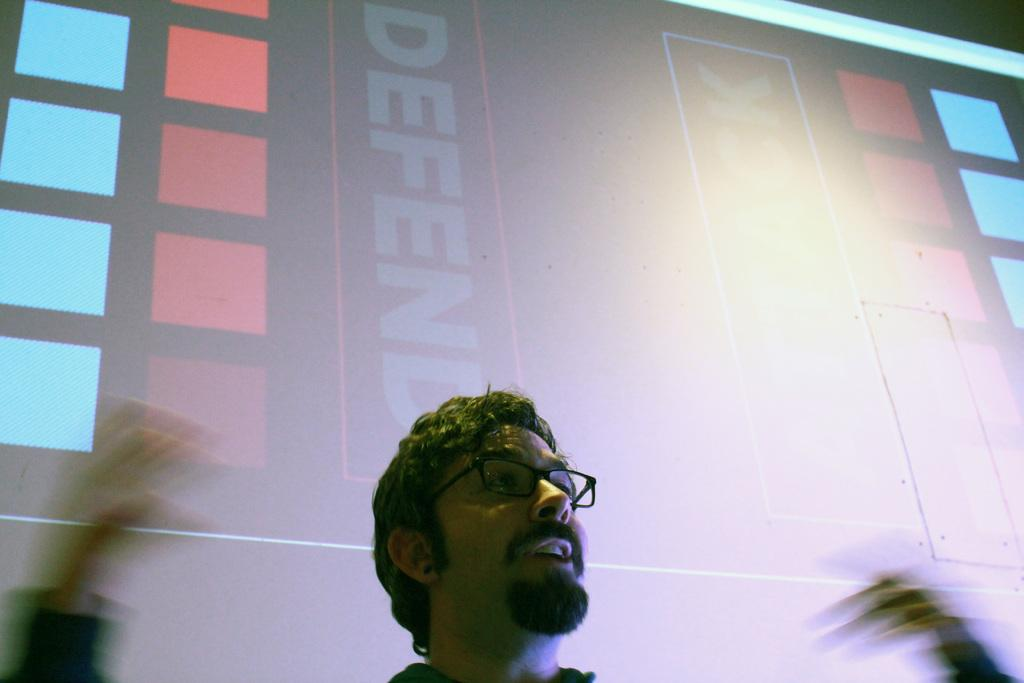Who is present in the image? There is a person in the image. What can be observed about the person's appearance? The person is wearing spectacles. What object is visible in the image? There is a board visible in the image. What is written or displayed on the board? There is text on the board. What type of rose can be seen growing on the island in the image? There is no rose or island present in the image. What kind of vessel is being used by the person in the image? The image does not show any vessel being used by the person. 